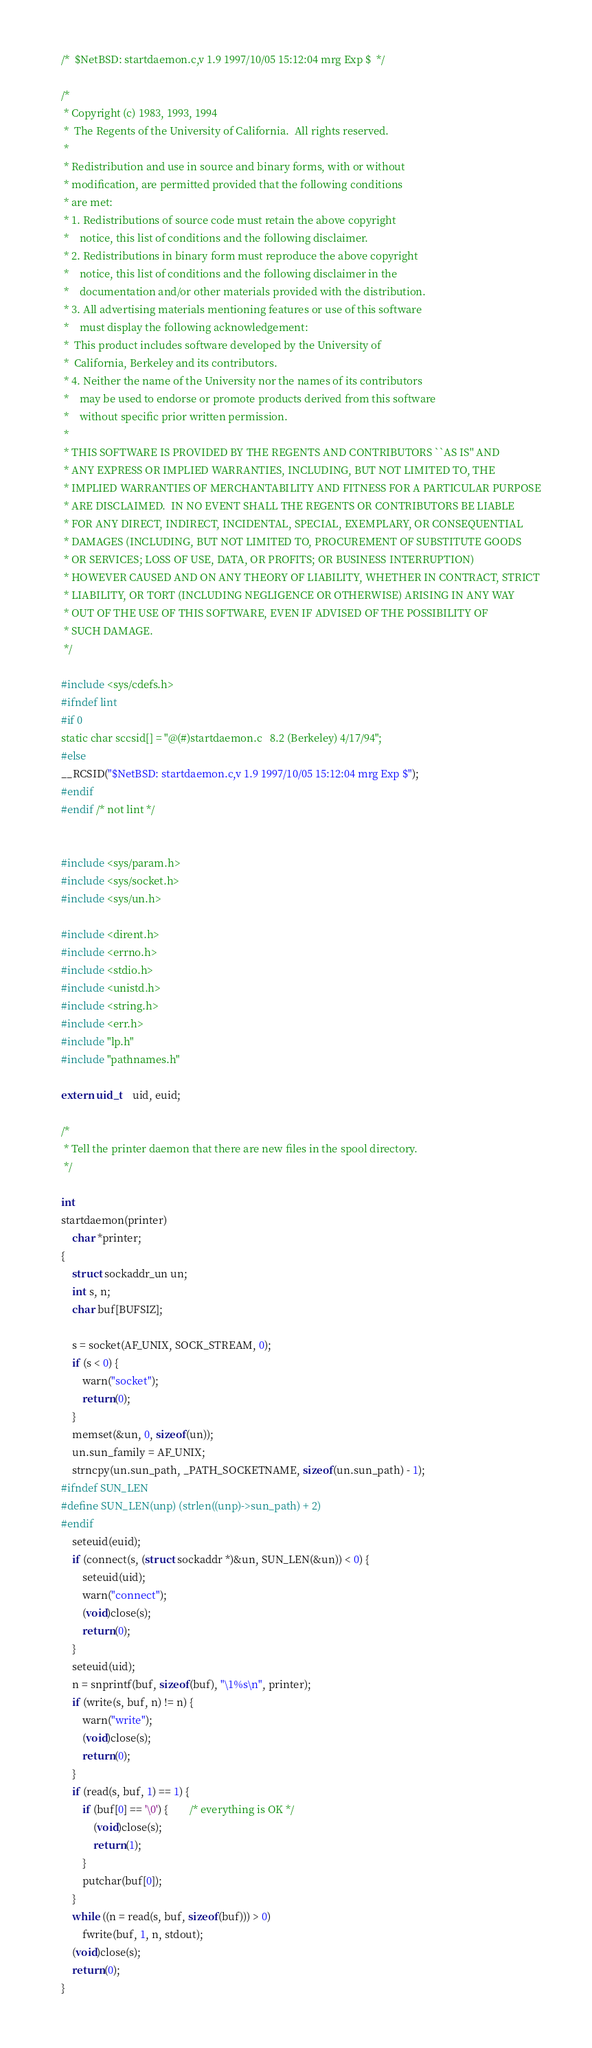<code> <loc_0><loc_0><loc_500><loc_500><_C_>/*	$NetBSD: startdaemon.c,v 1.9 1997/10/05 15:12:04 mrg Exp $	*/

/*
 * Copyright (c) 1983, 1993, 1994
 *	The Regents of the University of California.  All rights reserved.
 *
 * Redistribution and use in source and binary forms, with or without
 * modification, are permitted provided that the following conditions
 * are met:
 * 1. Redistributions of source code must retain the above copyright
 *    notice, this list of conditions and the following disclaimer.
 * 2. Redistributions in binary form must reproduce the above copyright
 *    notice, this list of conditions and the following disclaimer in the
 *    documentation and/or other materials provided with the distribution.
 * 3. All advertising materials mentioning features or use of this software
 *    must display the following acknowledgement:
 *	This product includes software developed by the University of
 *	California, Berkeley and its contributors.
 * 4. Neither the name of the University nor the names of its contributors
 *    may be used to endorse or promote products derived from this software
 *    without specific prior written permission.
 *
 * THIS SOFTWARE IS PROVIDED BY THE REGENTS AND CONTRIBUTORS ``AS IS'' AND
 * ANY EXPRESS OR IMPLIED WARRANTIES, INCLUDING, BUT NOT LIMITED TO, THE
 * IMPLIED WARRANTIES OF MERCHANTABILITY AND FITNESS FOR A PARTICULAR PURPOSE
 * ARE DISCLAIMED.  IN NO EVENT SHALL THE REGENTS OR CONTRIBUTORS BE LIABLE
 * FOR ANY DIRECT, INDIRECT, INCIDENTAL, SPECIAL, EXEMPLARY, OR CONSEQUENTIAL
 * DAMAGES (INCLUDING, BUT NOT LIMITED TO, PROCUREMENT OF SUBSTITUTE GOODS
 * OR SERVICES; LOSS OF USE, DATA, OR PROFITS; OR BUSINESS INTERRUPTION)
 * HOWEVER CAUSED AND ON ANY THEORY OF LIABILITY, WHETHER IN CONTRACT, STRICT
 * LIABILITY, OR TORT (INCLUDING NEGLIGENCE OR OTHERWISE) ARISING IN ANY WAY
 * OUT OF THE USE OF THIS SOFTWARE, EVEN IF ADVISED OF THE POSSIBILITY OF
 * SUCH DAMAGE.
 */

#include <sys/cdefs.h>
#ifndef lint
#if 0
static char sccsid[] = "@(#)startdaemon.c	8.2 (Berkeley) 4/17/94";
#else
__RCSID("$NetBSD: startdaemon.c,v 1.9 1997/10/05 15:12:04 mrg Exp $");
#endif
#endif /* not lint */


#include <sys/param.h>
#include <sys/socket.h>
#include <sys/un.h>

#include <dirent.h>
#include <errno.h>
#include <stdio.h>
#include <unistd.h>
#include <string.h>
#include <err.h>
#include "lp.h"
#include "pathnames.h"

extern uid_t	uid, euid;

/*
 * Tell the printer daemon that there are new files in the spool directory.
 */

int
startdaemon(printer)
	char *printer;
{
	struct sockaddr_un un;
	int s, n;
	char buf[BUFSIZ];

	s = socket(AF_UNIX, SOCK_STREAM, 0);
	if (s < 0) {
		warn("socket");
		return(0);
	}
	memset(&un, 0, sizeof(un));
	un.sun_family = AF_UNIX;
	strncpy(un.sun_path, _PATH_SOCKETNAME, sizeof(un.sun_path) - 1);
#ifndef SUN_LEN
#define SUN_LEN(unp) (strlen((unp)->sun_path) + 2)
#endif
	seteuid(euid);
	if (connect(s, (struct sockaddr *)&un, SUN_LEN(&un)) < 0) {
		seteuid(uid);
		warn("connect");
		(void)close(s);
		return(0);
	}
	seteuid(uid);
	n = snprintf(buf, sizeof(buf), "\1%s\n", printer);
	if (write(s, buf, n) != n) {
		warn("write");
		(void)close(s);
		return(0);
	}
	if (read(s, buf, 1) == 1) {
		if (buf[0] == '\0') {		/* everything is OK */
			(void)close(s);
			return(1);
		}
		putchar(buf[0]);
	}
	while ((n = read(s, buf, sizeof(buf))) > 0)
		fwrite(buf, 1, n, stdout);
	(void)close(s);
	return(0);
}
</code> 